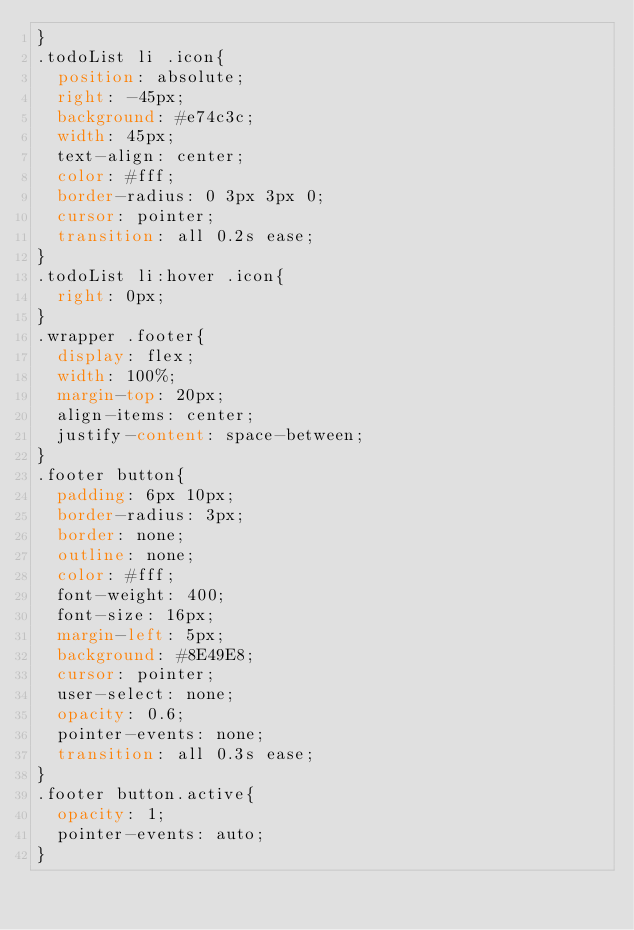Convert code to text. <code><loc_0><loc_0><loc_500><loc_500><_CSS_>}
.todoList li .icon{
  position: absolute;
  right: -45px;
  background: #e74c3c;
  width: 45px;
  text-align: center;
  color: #fff;
  border-radius: 0 3px 3px 0;
  cursor: pointer;
  transition: all 0.2s ease;
}
.todoList li:hover .icon{
  right: 0px;
}
.wrapper .footer{
  display: flex;
  width: 100%;
  margin-top: 20px;
  align-items: center;
  justify-content: space-between;
}
.footer button{
  padding: 6px 10px;
  border-radius: 3px;
  border: none;
  outline: none;
  color: #fff;
  font-weight: 400;
  font-size: 16px;
  margin-left: 5px;
  background: #8E49E8;
  cursor: pointer;
  user-select: none;
  opacity: 0.6;
  pointer-events: none;
  transition: all 0.3s ease;
}
.footer button.active{
  opacity: 1;
  pointer-events: auto;
}
</code> 